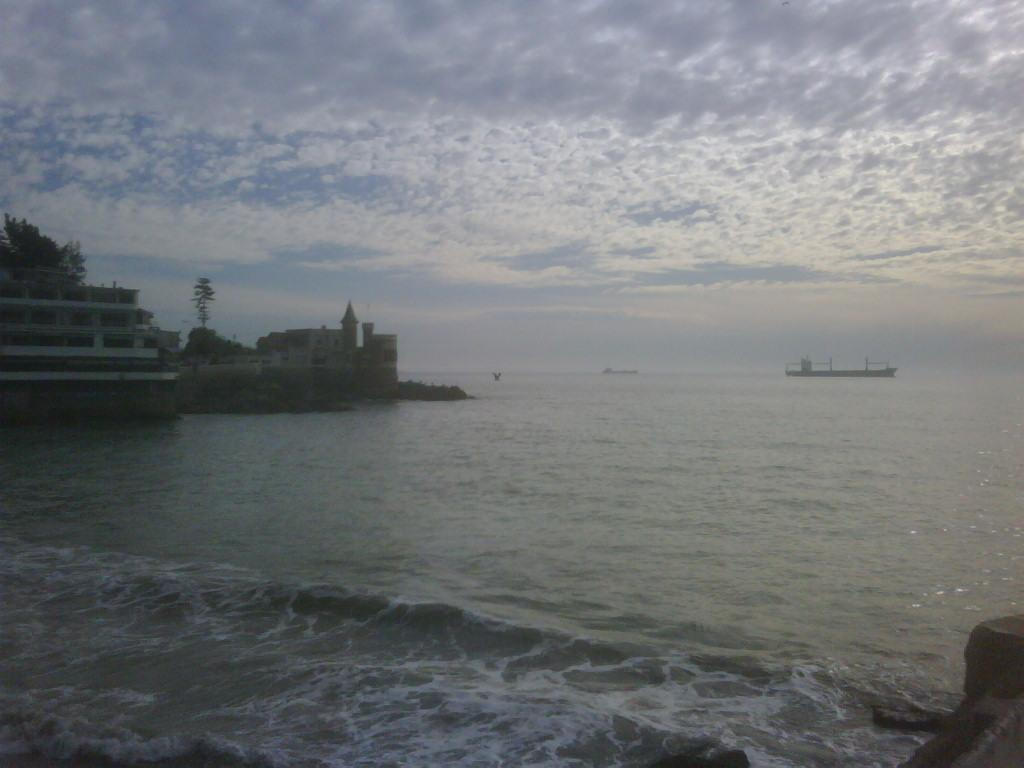What is in the water in the image? There is a boat in the water in the image. What can be observed about the water's movement? Waves are visible in the water. What is located on the left side of the image? There are buildings and trees on the left side of the image. What type of lace can be seen on the boat in the image? There is no lace present on the boat in the image. How many snails can be seen crawling on the buildings in the image? There are no snails visible on the buildings in the image. 